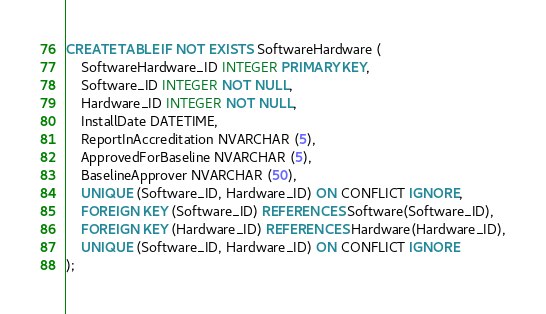Convert code to text. <code><loc_0><loc_0><loc_500><loc_500><_SQL_>CREATE TABLE IF NOT EXISTS SoftwareHardware (
    SoftwareHardware_ID INTEGER PRIMARY KEY,
    Software_ID INTEGER NOT NULL,
    Hardware_ID INTEGER NOT NULL,
    InstallDate DATETIME,
    ReportInAccreditation NVARCHAR (5),
    ApprovedForBaseline NVARCHAR (5),
    BaselineApprover NVARCHAR (50),
    UNIQUE (Software_ID, Hardware_ID) ON CONFLICT IGNORE,
    FOREIGN KEY (Software_ID) REFERENCES Software(Software_ID),
    FOREIGN KEY (Hardware_ID) REFERENCES Hardware(Hardware_ID),
    UNIQUE (Software_ID, Hardware_ID) ON CONFLICT IGNORE
);</code> 